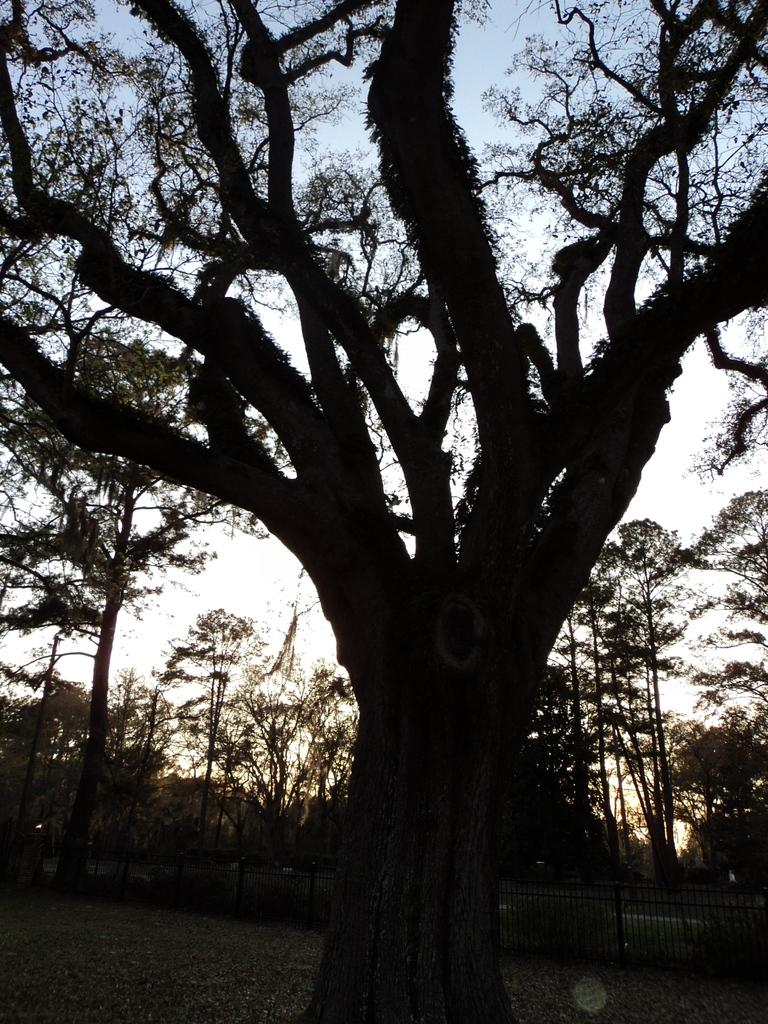What type of vegetation can be seen in the image? There is a group of trees in the image. What structure is present in the image? There is a fence in the image. What can be seen in the background of the image? The sky is visible in the background of the image. What type of popcorn is being served at the party in the image? There is no party or popcorn present in the image; it features a group of trees and a fence. Who is the partner of the person standing next to the fence in the image? There is no person standing next to the fence in the image, as it only shows a group of trees and a fence. 